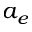Convert formula to latex. <formula><loc_0><loc_0><loc_500><loc_500>a _ { e }</formula> 